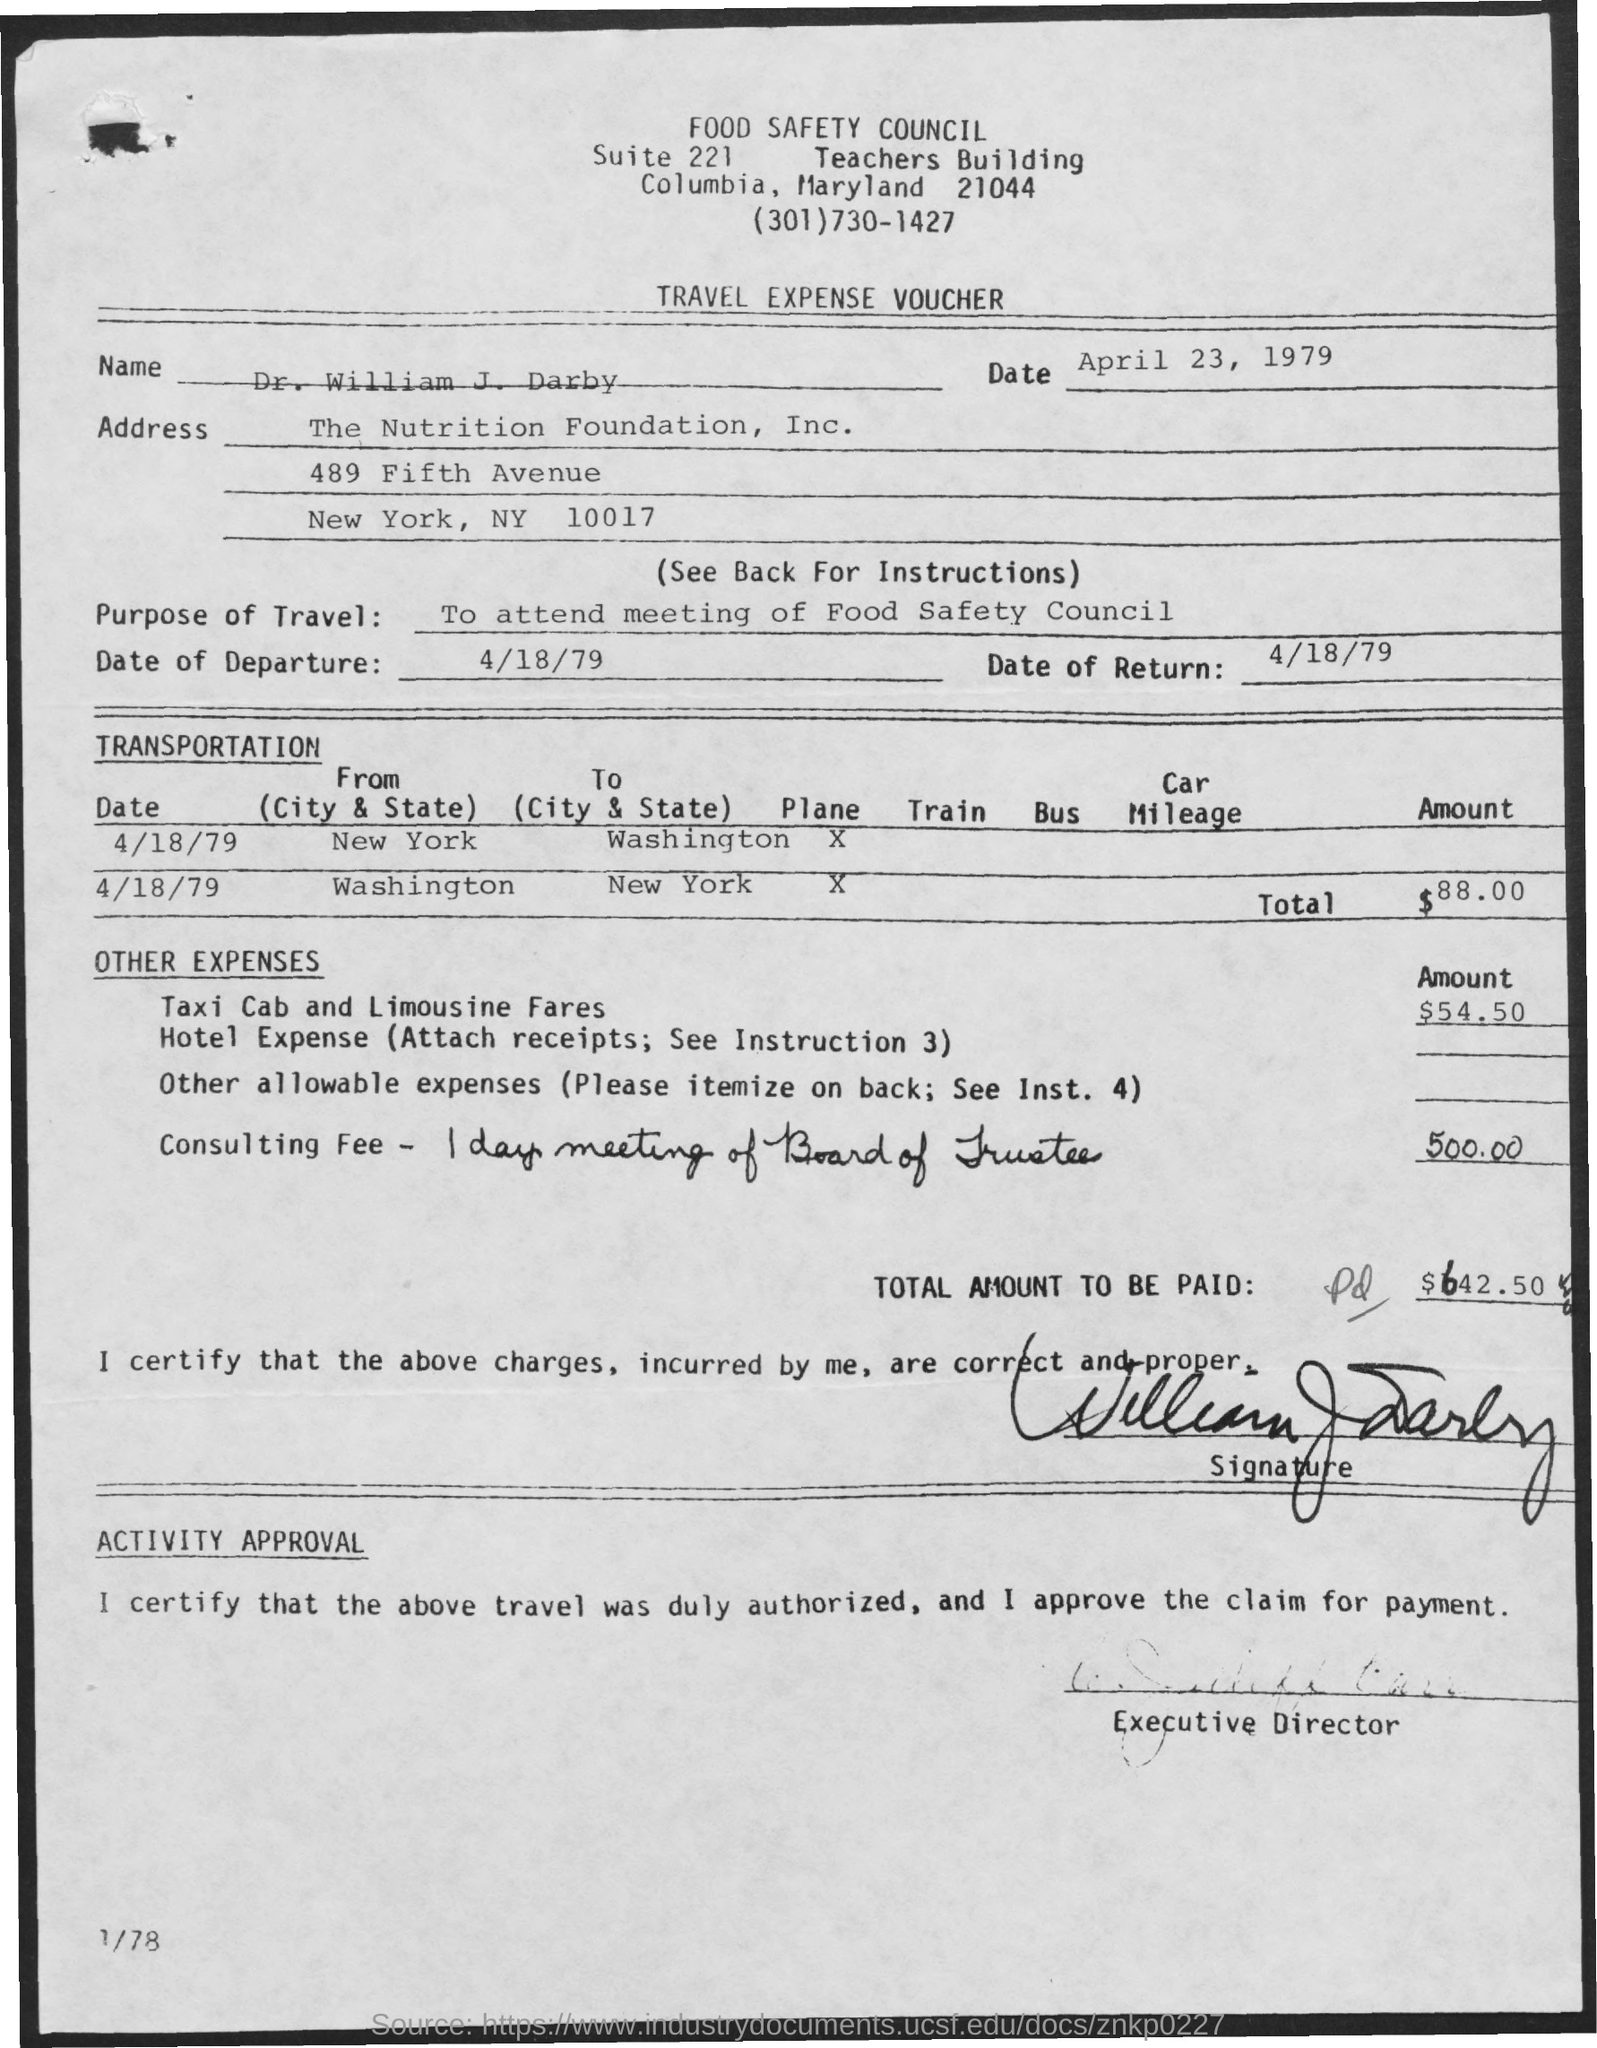What is the total amount to be reimbursed according to this voucher? The total amount to be reimbursed as per the voucher is $642.50. 